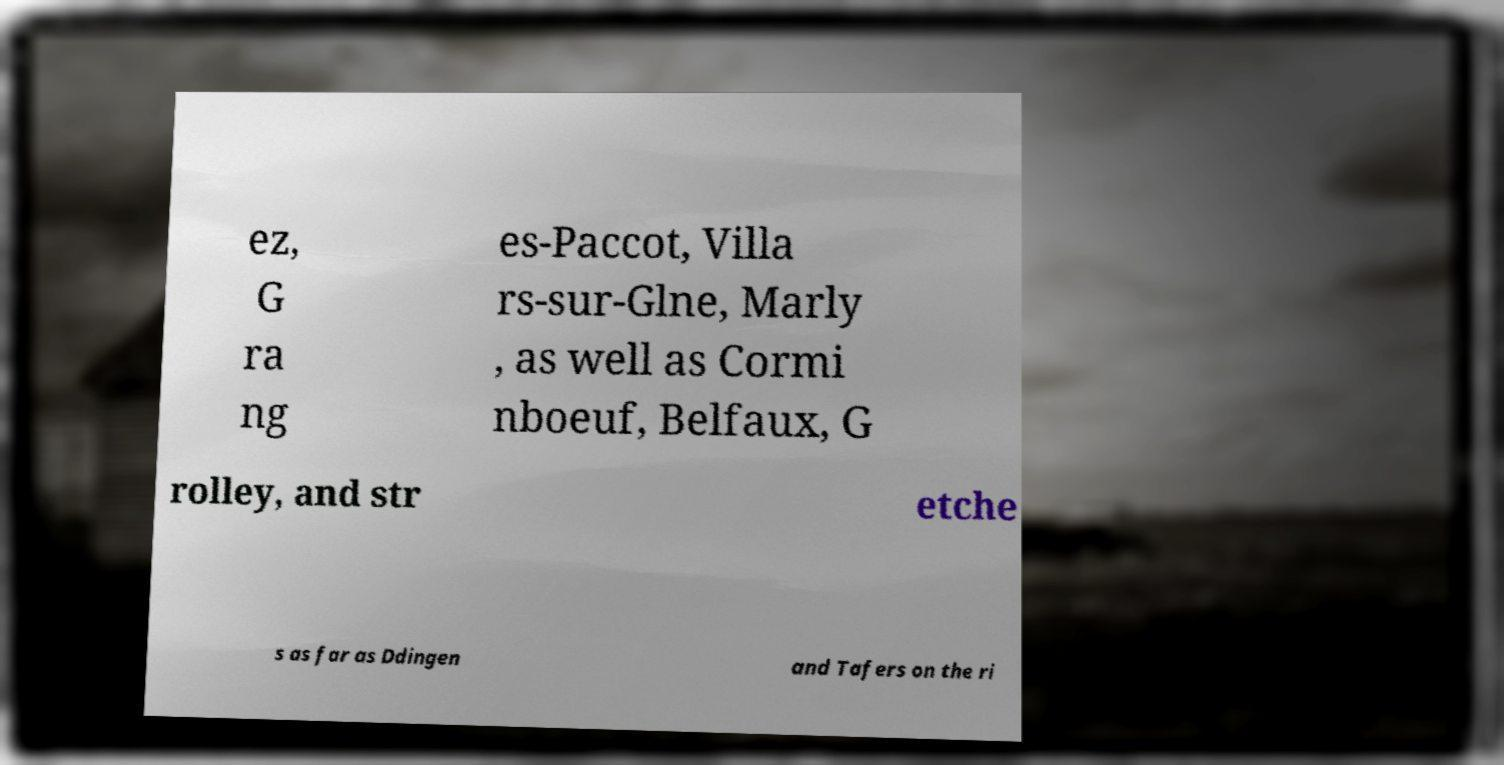There's text embedded in this image that I need extracted. Can you transcribe it verbatim? ez, G ra ng es-Paccot, Villa rs-sur-Glne, Marly , as well as Cormi nboeuf, Belfaux, G rolley, and str etche s as far as Ddingen and Tafers on the ri 